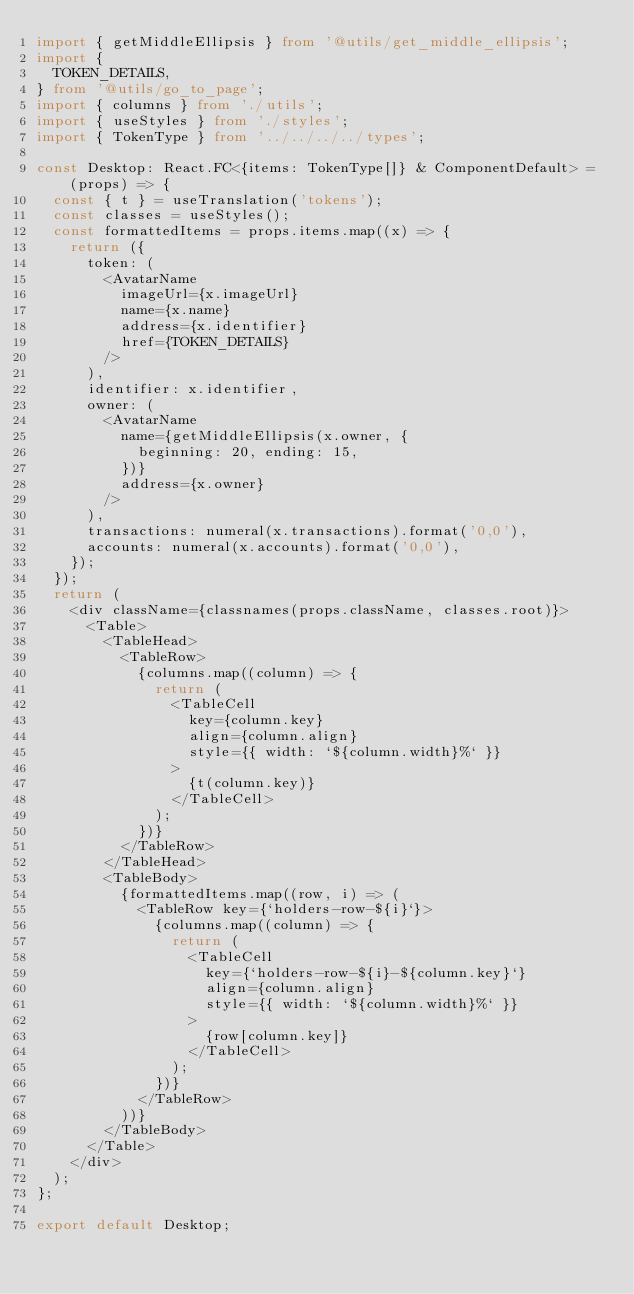<code> <loc_0><loc_0><loc_500><loc_500><_TypeScript_>import { getMiddleEllipsis } from '@utils/get_middle_ellipsis';
import {
  TOKEN_DETAILS,
} from '@utils/go_to_page';
import { columns } from './utils';
import { useStyles } from './styles';
import { TokenType } from '../../../../types';

const Desktop: React.FC<{items: TokenType[]} & ComponentDefault> = (props) => {
  const { t } = useTranslation('tokens');
  const classes = useStyles();
  const formattedItems = props.items.map((x) => {
    return ({
      token: (
        <AvatarName
          imageUrl={x.imageUrl}
          name={x.name}
          address={x.identifier}
          href={TOKEN_DETAILS}
        />
      ),
      identifier: x.identifier,
      owner: (
        <AvatarName
          name={getMiddleEllipsis(x.owner, {
            beginning: 20, ending: 15,
          })}
          address={x.owner}
        />
      ),
      transactions: numeral(x.transactions).format('0,0'),
      accounts: numeral(x.accounts).format('0,0'),
    });
  });
  return (
    <div className={classnames(props.className, classes.root)}>
      <Table>
        <TableHead>
          <TableRow>
            {columns.map((column) => {
              return (
                <TableCell
                  key={column.key}
                  align={column.align}
                  style={{ width: `${column.width}%` }}
                >
                  {t(column.key)}
                </TableCell>
              );
            })}
          </TableRow>
        </TableHead>
        <TableBody>
          {formattedItems.map((row, i) => (
            <TableRow key={`holders-row-${i}`}>
              {columns.map((column) => {
                return (
                  <TableCell
                    key={`holders-row-${i}-${column.key}`}
                    align={column.align}
                    style={{ width: `${column.width}%` }}
                  >
                    {row[column.key]}
                  </TableCell>
                );
              })}
            </TableRow>
          ))}
        </TableBody>
      </Table>
    </div>
  );
};

export default Desktop;
</code> 